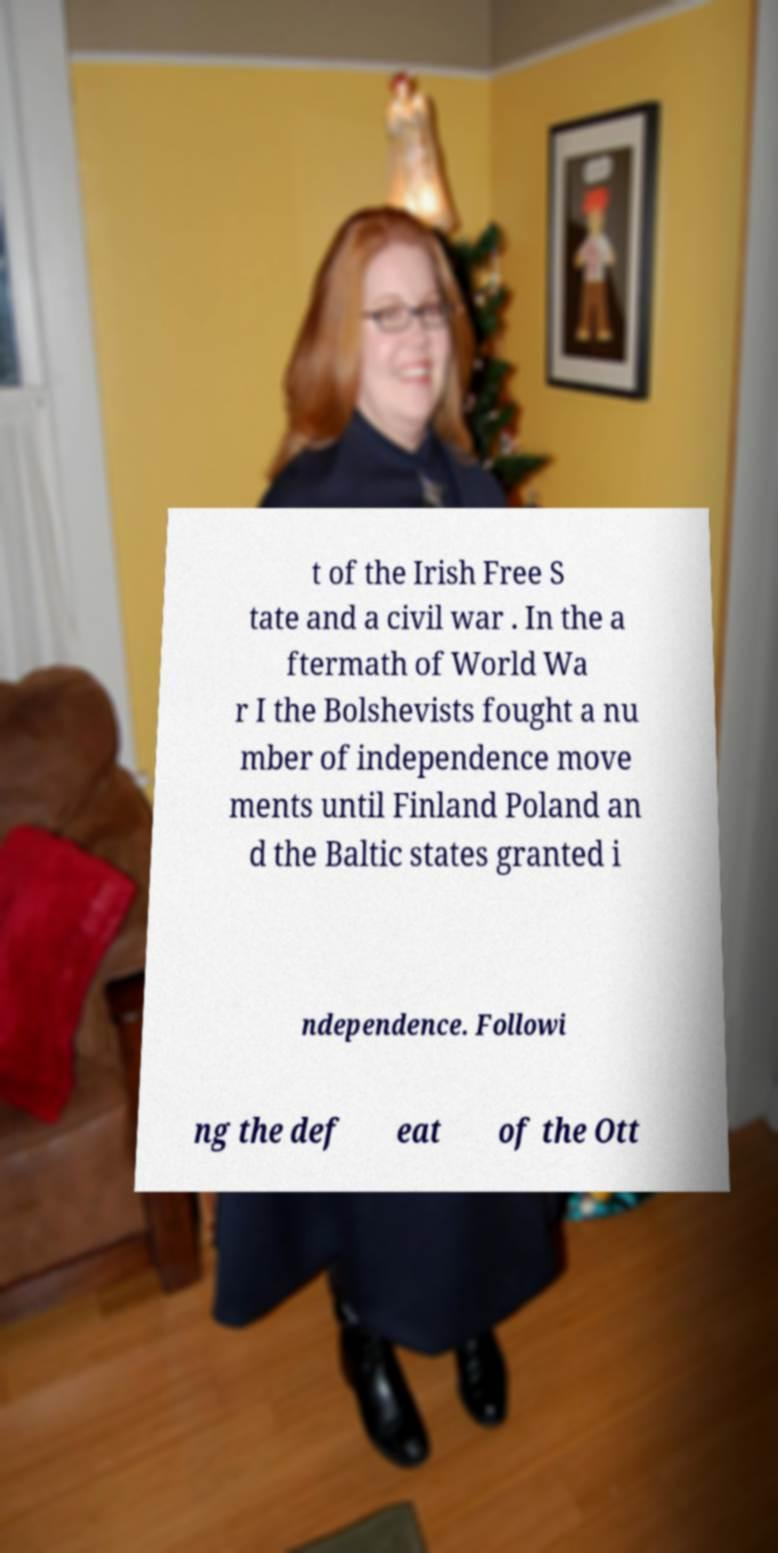Could you assist in decoding the text presented in this image and type it out clearly? t of the Irish Free S tate and a civil war . In the a ftermath of World Wa r I the Bolshevists fought a nu mber of independence move ments until Finland Poland an d the Baltic states granted i ndependence. Followi ng the def eat of the Ott 